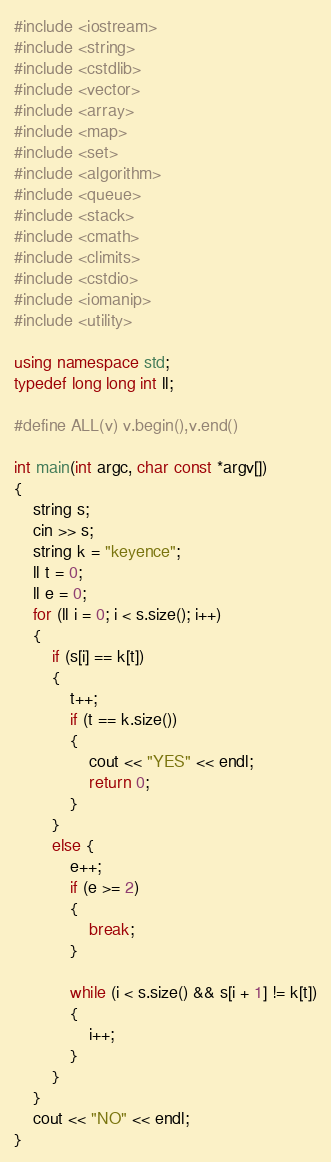<code> <loc_0><loc_0><loc_500><loc_500><_C++_>#include <iostream>
#include <string>
#include <cstdlib>
#include <vector>
#include <array>
#include <map>
#include <set>
#include <algorithm>
#include <queue>
#include <stack>
#include <cmath>
#include <climits>
#include <cstdio>
#include <iomanip>
#include <utility>

using namespace std;
typedef long long int ll;

#define ALL(v) v.begin(),v.end()

int main(int argc, char const *argv[])
{
    string s;
    cin >> s;
    string k = "keyence";
    ll t = 0;
    ll e = 0;
    for (ll i = 0; i < s.size(); i++)
    {
        if (s[i] == k[t])
        {
            t++;
            if (t == k.size())
            {
                cout << "YES" << endl;
                return 0;
            }
        }
        else {
            e++;
            if (e >= 2)
            {
                break;
            }

            while (i < s.size() && s[i + 1] != k[t])
            {
                i++;
            }
        }
    }
    cout << "NO" << endl;
}</code> 